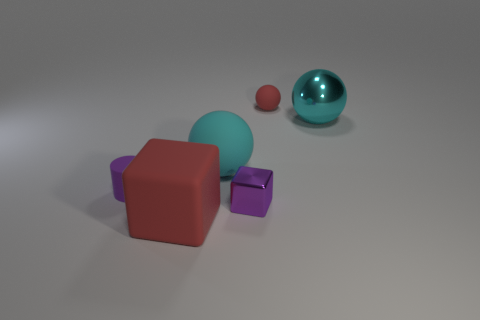Can you describe the lighting in this scene? The lighting in the scene is soft and diffuse, casting gentle shadows and giving the image a calm and serene atmosphere. 